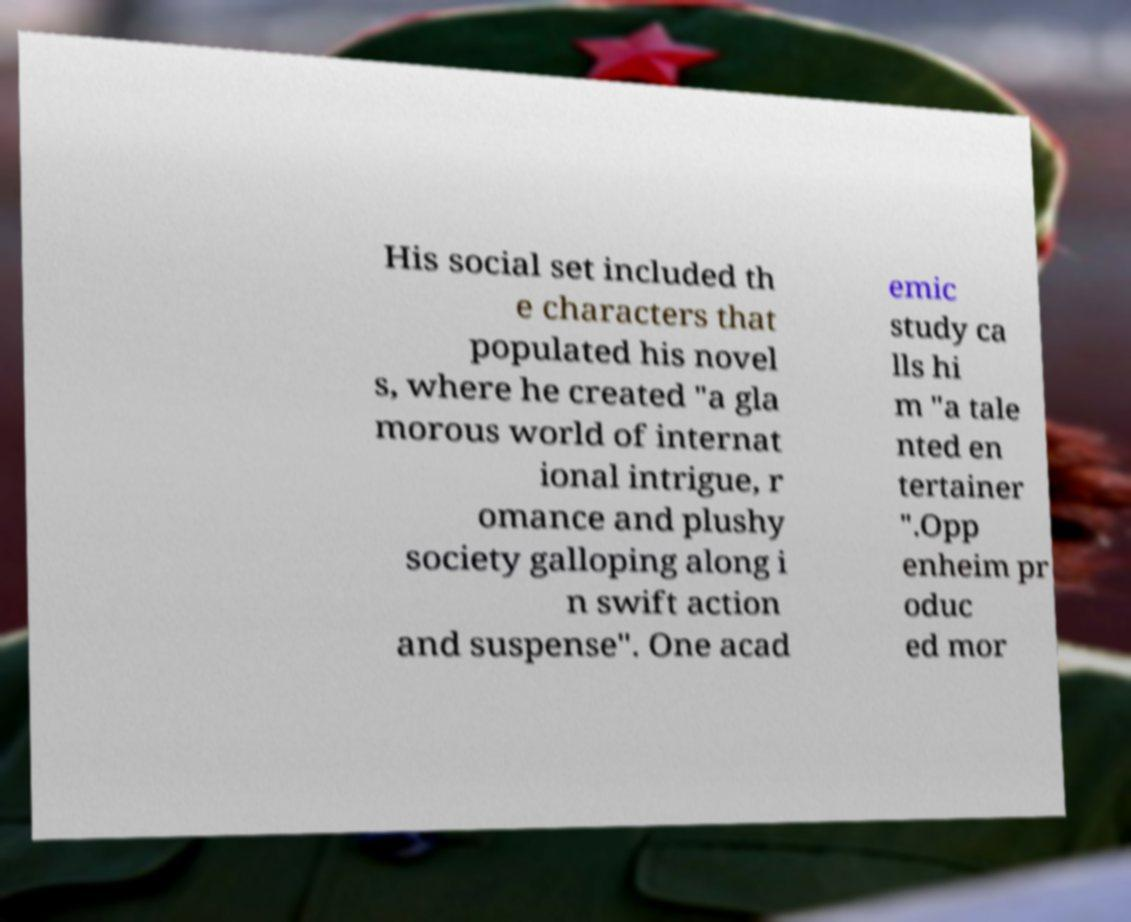I need the written content from this picture converted into text. Can you do that? His social set included th e characters that populated his novel s, where he created "a gla morous world of internat ional intrigue, r omance and plushy society galloping along i n swift action and suspense". One acad emic study ca lls hi m "a tale nted en tertainer ".Opp enheim pr oduc ed mor 